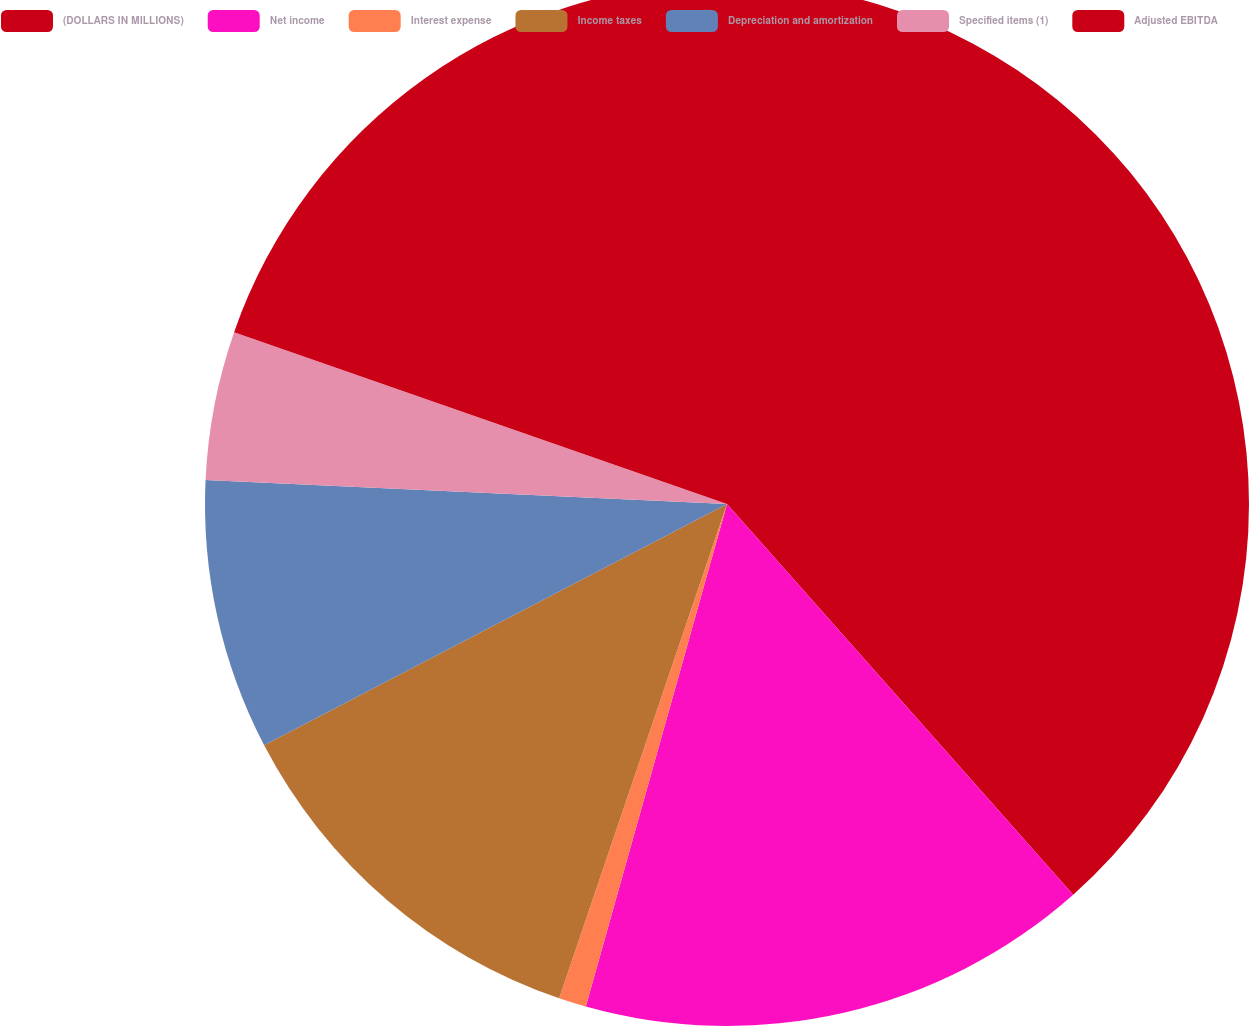Convert chart. <chart><loc_0><loc_0><loc_500><loc_500><pie_chart><fcel>(DOLLARS IN MILLIONS)<fcel>Net income<fcel>Interest expense<fcel>Income taxes<fcel>Depreciation and amortization<fcel>Specified items (1)<fcel>Adjusted EBITDA<nl><fcel>38.46%<fcel>15.9%<fcel>0.85%<fcel>12.14%<fcel>8.38%<fcel>4.61%<fcel>19.66%<nl></chart> 